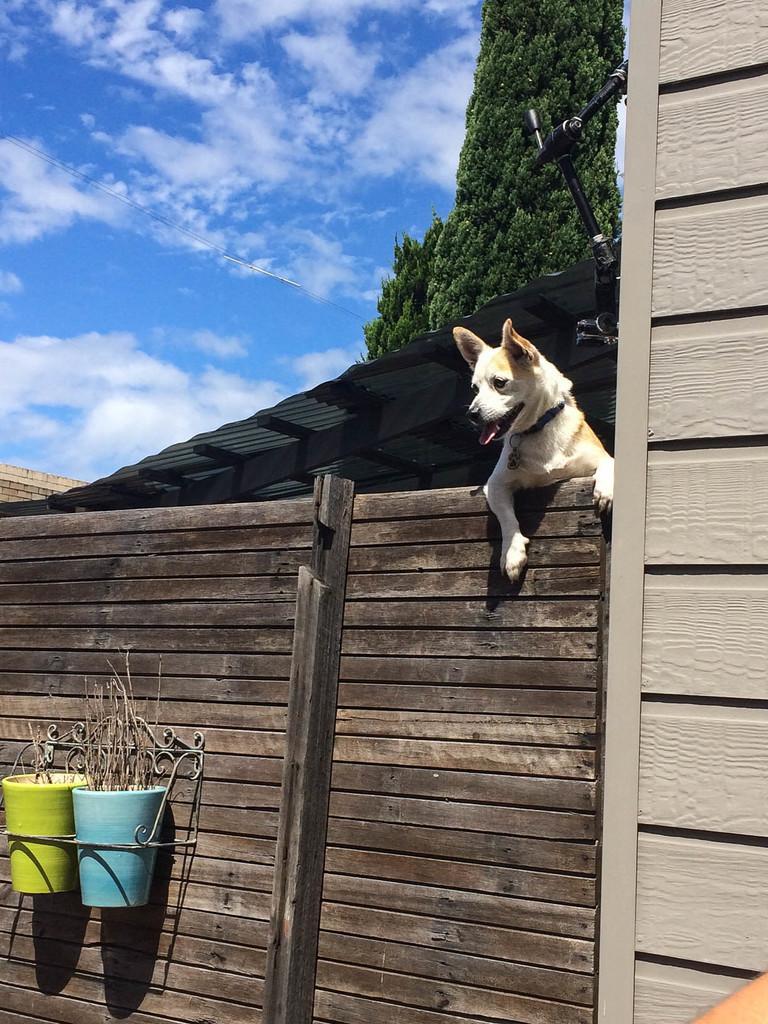Describe this image in one or two sentences. In this image in the front there is a wooden fence and on the top of the wooden fence there is a dog and in front of the wooden fence, there are ports which are hanging. In the background there is a shelter, there are trees and the sky is cloudy. 